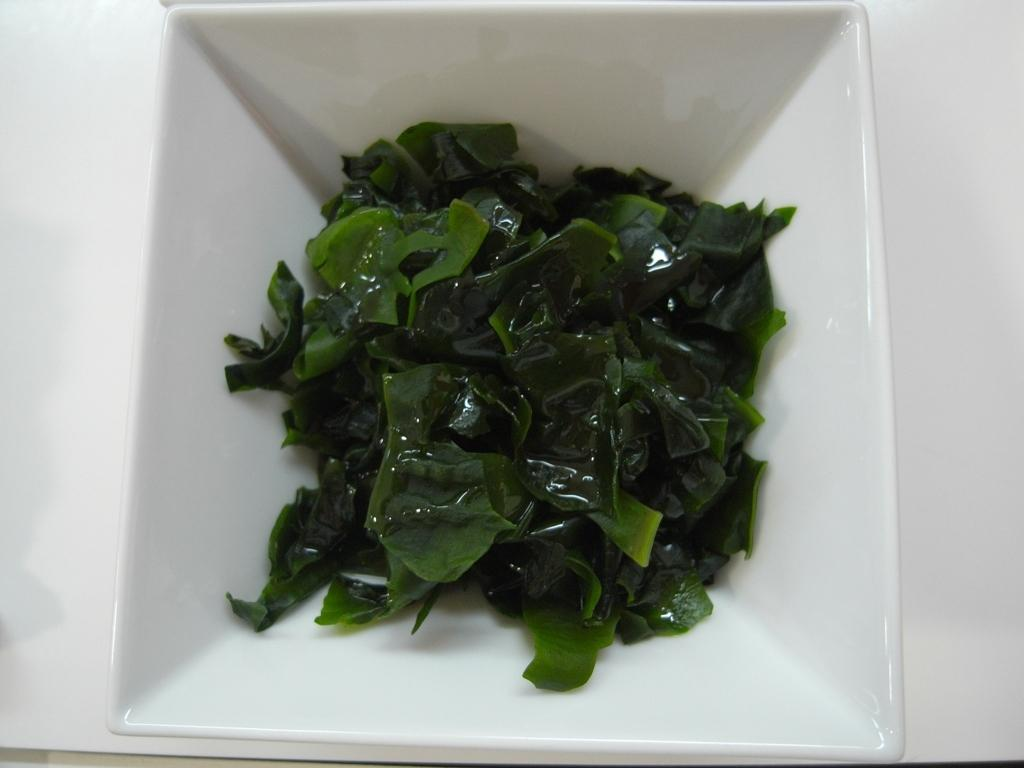What is on the table in the image? There is a bowl on the table in the image. What is inside the bowl? The bowl contains leafy vegetables. What type of religious symbol can be seen on the leafy vegetables in the image? There are no religious symbols present on the leafy vegetables in the image. 